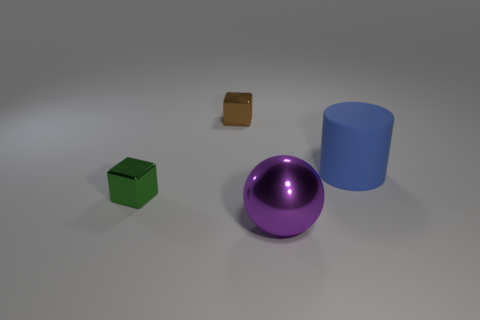Add 3 big brown shiny balls. How many objects exist? 7 Subtract all brown blocks. How many blocks are left? 1 Subtract 1 cubes. How many cubes are left? 1 Subtract all balls. How many objects are left? 3 Subtract all green blocks. Subtract all purple cylinders. How many blocks are left? 1 Subtract all cyan balls. How many brown blocks are left? 1 Subtract all blue rubber objects. Subtract all purple things. How many objects are left? 2 Add 2 big cylinders. How many big cylinders are left? 3 Add 3 large brown metal cubes. How many large brown metal cubes exist? 3 Subtract 0 brown spheres. How many objects are left? 4 